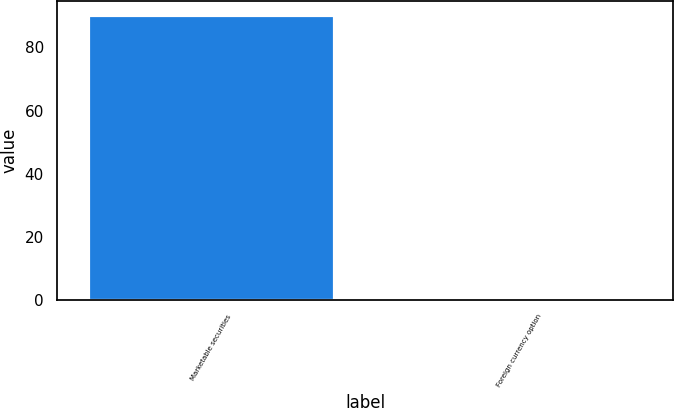Convert chart. <chart><loc_0><loc_0><loc_500><loc_500><bar_chart><fcel>Marketable securities<fcel>Foreign currency option<nl><fcel>90.31<fcel>0.2<nl></chart> 